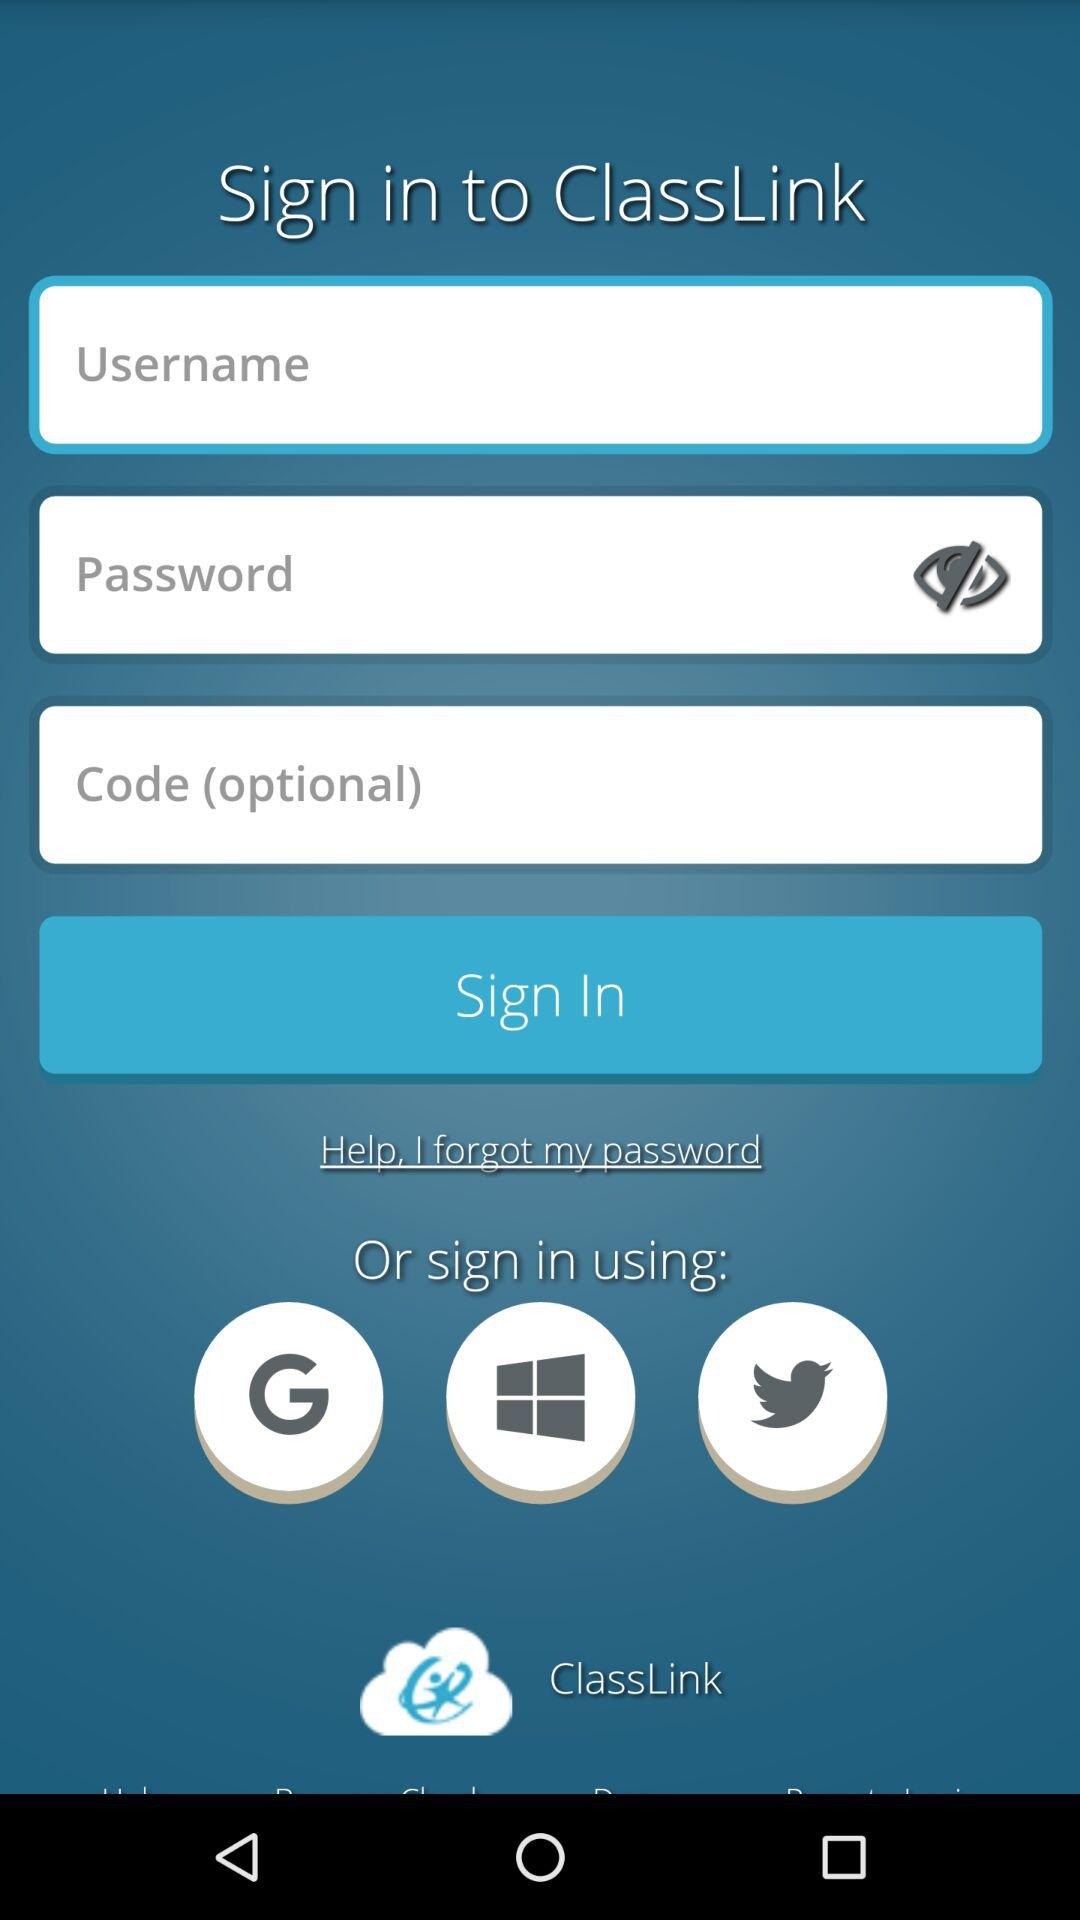What are the different applications through which we can sign in? You can sign in through "Google", "Microsoft" and "Twitter". 